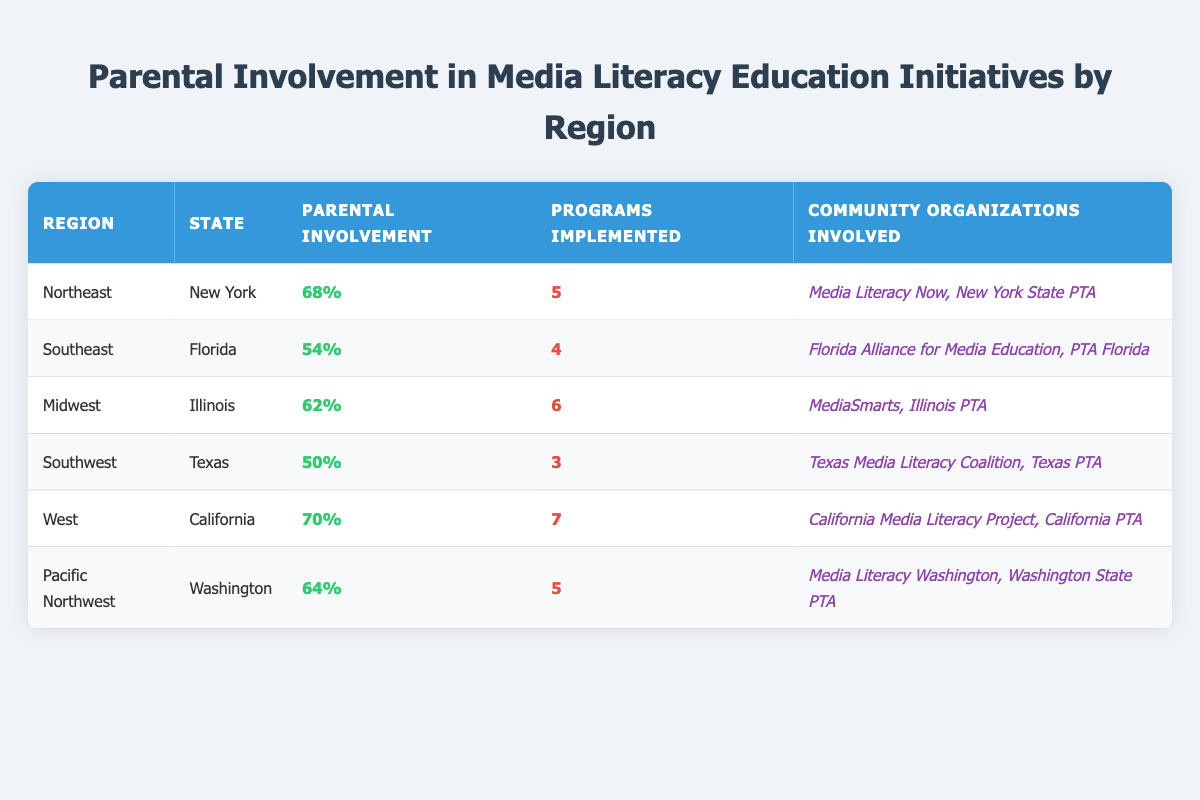What is the parental involvement percentage in the Northeast region? According to the table, the parental involvement percentage for the Northeast region is listed directly next to it. The percentage is 68%.
Answer: 68% Which region has the highest parental involvement percentage? By examining the percentages in the table, California from the West region has the highest percentage at 70%.
Answer: California (West) How many programs were implemented in Florida? The table lists the number of programs implemented in Florida specifically as 4.
Answer: 4 What is the average parental involvement percentage across all regions? To find the average, we sum the parental involvement percentages: 68 + 54 + 62 + 50 + 70 + 64 = 368. Then, we divide by the number of regions, which is 6. Thus, the average is 368/6 = 61.33.
Answer: 61.33% Is there a region where parental involvement is below 55%? By looking through the table, Texas has a parental involvement percentage of 50%, which is below 55%. Therefore, the answer is yes.
Answer: Yes How does the number of programs implemented in the Midwest compare to the Southwest? The Midwest has 6 programs implemented while the Southwest has 3. The comparison shows that the Midwest has more programs (6 - 3 = 3).
Answer: The Midwest has 3 more programs than the Southwest Which community organizations are involved in the Pacific Northwest? In the Pacific Northwest region (Washington), the community organizations involved are detailed as Media Literacy Washington and Washington State PTA.
Answer: Media Literacy Washington, Washington State PTA Is parental involvement in media literacy education higher in the West or Southeast region? The parental involvement in the West is 70% while in the Southeast it is 54%. Thus, the West region has a higher percentage of parental involvement.
Answer: West region is higher What is the total number of community organizations involved across all regions? Counting the organizations: Northeast (2) + Southeast (2) + Midwest (2) + Southwest (2) + West (2) + Pacific Northwest (2) = 12 total organizations involved.
Answer: 12 organizations 